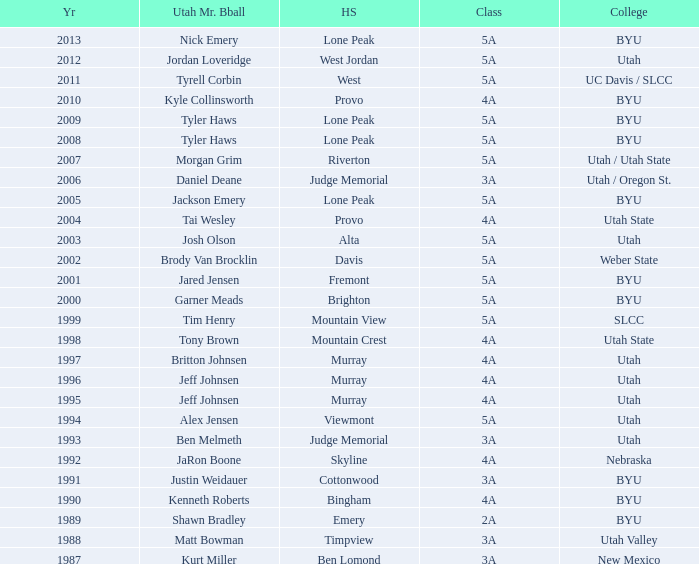Where did Tyler Haws, 2009 Utah Mr. Basketball, go to high school? Lone Peak. 